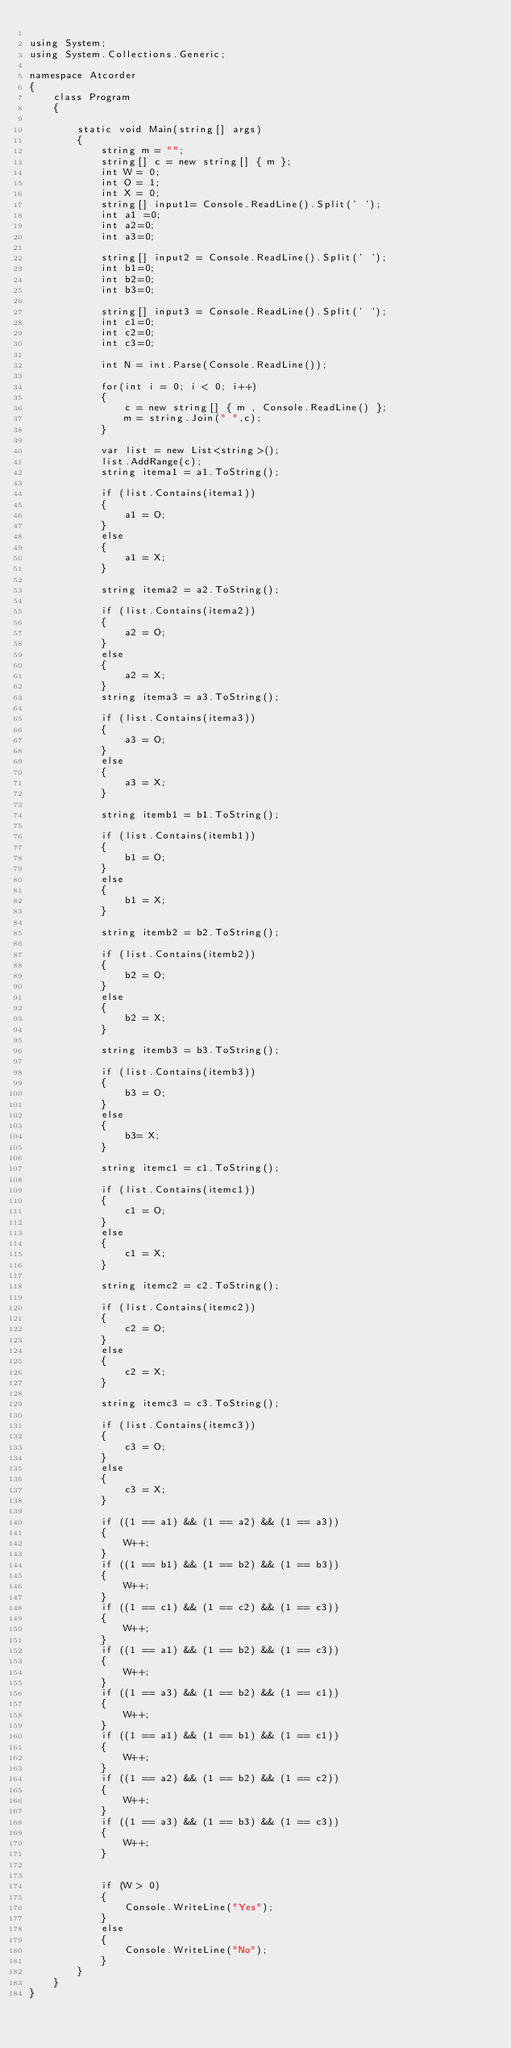Convert code to text. <code><loc_0><loc_0><loc_500><loc_500><_C#_>
using System;
using System.Collections.Generic;

namespace Atcorder
{
    class Program
    {
        
        static void Main(string[] args)
        {
            string m = "";
            string[] c = new string[] { m };
            int W = 0;
            int O = 1;
            int X = 0;
            string[] input1= Console.ReadLine().Split(' ');
            int a1 =0;
            int a2=0;
            int a3=0;

            string[] input2 = Console.ReadLine().Split(' ');
            int b1=0;
            int b2=0;
            int b3=0;

            string[] input3 = Console.ReadLine().Split(' ');
            int c1=0;
            int c2=0;
            int c3=0;

            int N = int.Parse(Console.ReadLine());

            for(int i = 0; i < 0; i++)
            {
                c = new string[] { m , Console.ReadLine() };
                m = string.Join(" ",c);
            }

            var list = new List<string>();
            list.AddRange(c);
            string itema1 = a1.ToString();

            if (list.Contains(itema1))
            {
                a1 = O;
            }
            else
            {
                a1 = X;
            }

            string itema2 = a2.ToString();

            if (list.Contains(itema2))
            {
                a2 = O;
            }
            else
            {
                a2 = X;
            }
            string itema3 = a3.ToString();

            if (list.Contains(itema3))
            {
                a3 = O;
            }
            else
            {
                a3 = X;
            }

            string itemb1 = b1.ToString();

            if (list.Contains(itemb1))
            {
                b1 = O;
            }
            else
            {
                b1 = X;
            }
            
            string itemb2 = b2.ToString();

            if (list.Contains(itemb2))
            {
                b2 = O;
            }
            else
            {
                b2 = X;
            }

            string itemb3 = b3.ToString();

            if (list.Contains(itemb3))
            {
                b3 = O;
            }
            else
            {
                b3= X;
            }

            string itemc1 = c1.ToString();

            if (list.Contains(itemc1))
            {
                c1 = O;
            }
            else
            {
                c1 = X;
            }

            string itemc2 = c2.ToString();

            if (list.Contains(itemc2))
            {
                c2 = O;
            }
            else
            {
                c2 = X;
            }

            string itemc3 = c3.ToString();

            if (list.Contains(itemc3))
            {
                c3 = O;
            }
            else
            {
                c3 = X;
            }

            if ((1 == a1) && (1 == a2) && (1 == a3))
            {
                W++;
            }
            if ((1 == b1) && (1 == b2) && (1 == b3))
            {
                W++;
            }
            if ((1 == c1) && (1 == c2) && (1 == c3))
            {
                W++;
            }
            if ((1 == a1) && (1 == b2) && (1 == c3))
            {
                W++;
            }
            if ((1 == a3) && (1 == b2) && (1 == c1))
            {
                W++;
            }
            if ((1 == a1) && (1 == b1) && (1 == c1))
            {
                W++;
            }
            if ((1 == a2) && (1 == b2) && (1 == c2))
            {
                W++;
            }
            if ((1 == a3) && (1 == b3) && (1 == c3))
            {
                W++;
            }


            if (W > 0)
            {
                Console.WriteLine("Yes");
            }
            else
            {
                Console.WriteLine("No");
            }
        }
    }
}
</code> 